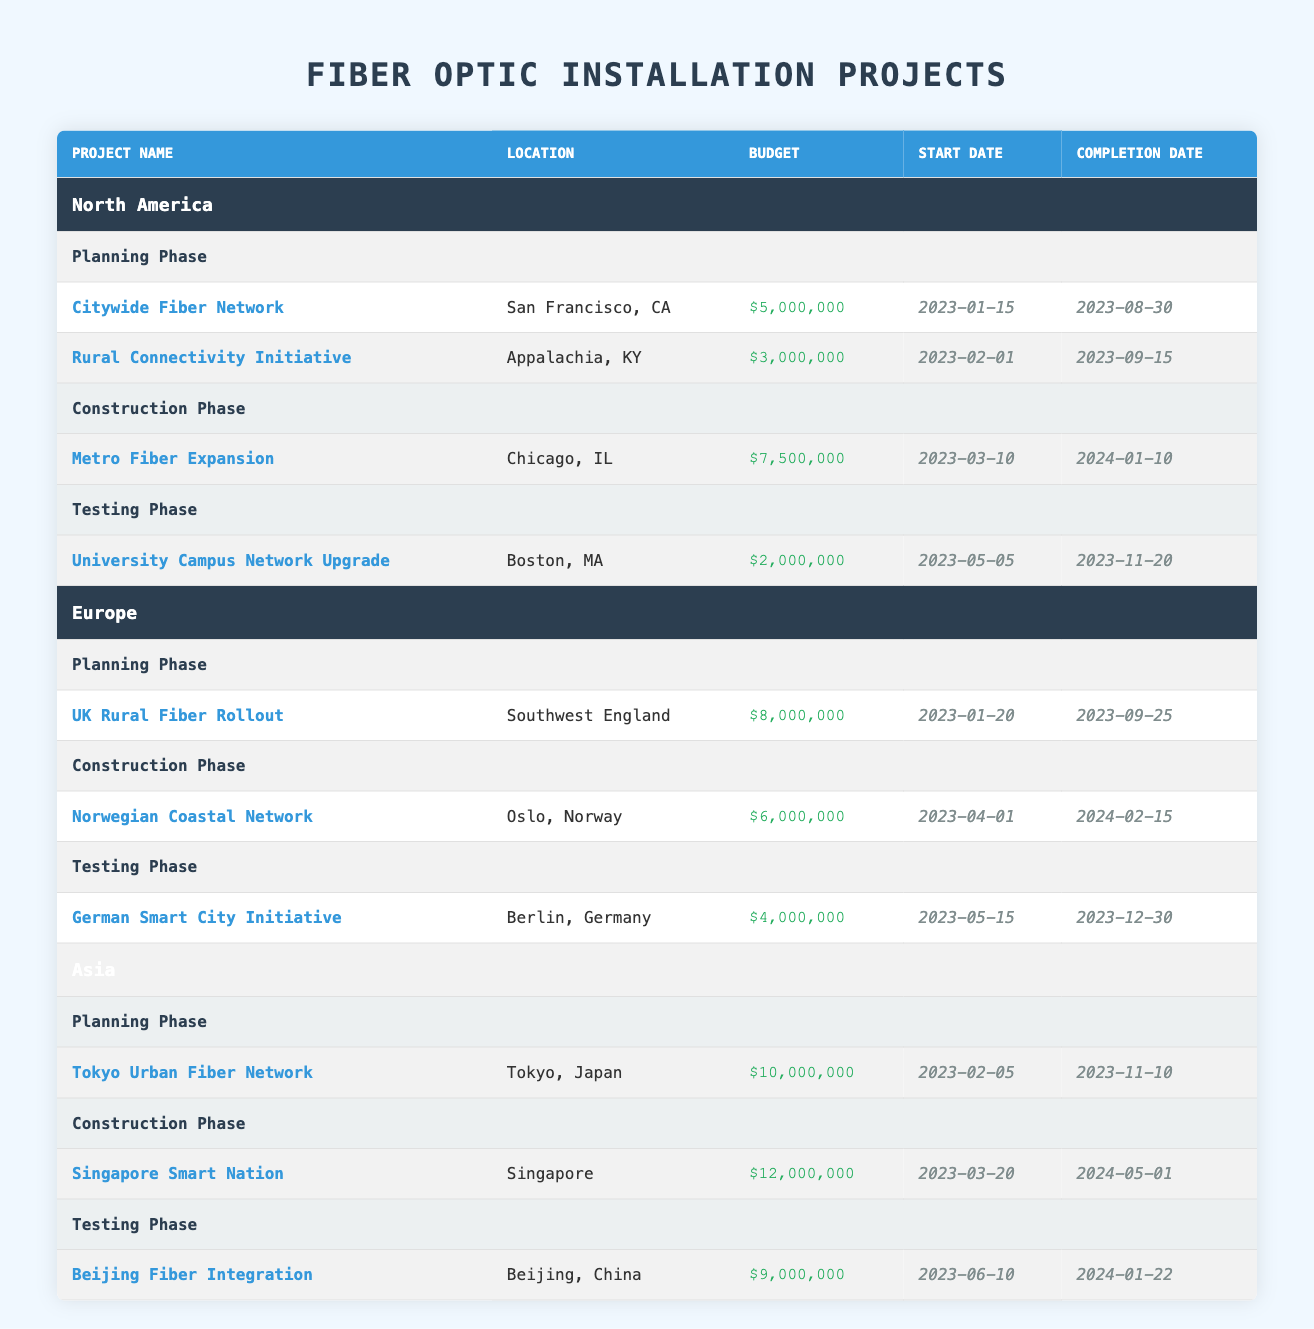What is the budget for the "Citywide Fiber Network" project? The budget can be found in the row corresponding to the "Citywide Fiber Network" project under the "North America" section and the "Planning Phase." The budget listed is $5,000,000.
Answer: $5,000,000 How many projects are currently in the Construction Phase in North America? There is one project listed under the "Construction Phase" for North America, which is the "Metro Fiber Expansion."
Answer: 1 What is the total budget for projects in the Testing Phase across all regions? The budgets for the Testing Phase projects are: $2,000,000 (University Campus Network Upgrade) + $4,000,000 (German Smart City Initiative) + $9,000,000 (Beijing Fiber Integration) = $15,000,000.
Answer: $15,000,000 Is there a fiber optic project located in Berlin, Germany? The table includes a project in Berlin, Germany, specifically the "German Smart City Initiative" under the "Testing Phase." Therefore, the answer is yes.
Answer: Yes Which region has the highest budget for a single Planning Phase project? The Planning Phase project with the highest budget is "Tokyo Urban Fiber Network" in Asia, with a budget of $10,000,000. This is compared against other single projects in Europe and North America.
Answer: Asia How many projects are listed under the Construction Phase in Europe and what is their total budget? Europe has one Construction Phase project, which is the "Norwegian Coastal Network" with a budget of $6,000,000. Since there is only one project, the total budget is also $6,000,000.
Answer: 1 project, $6,000,000 What is the difference in budget between the "Rural Connectivity Initiative" and the "Singapore Smart Nation" projects? The "Rural Connectivity Initiative" has a budget of $3,000,000, and the "Singapore Smart Nation" has a budget of $12,000,000. The difference is calculated as $12,000,000 - $3,000,000 = $9,000,000.
Answer: $9,000,000 Are there more projects in the Planning or Construction phases across all regions? In total, Planning Phases have 4 projects (2 in North America, 1 in Europe, 1 in Asia), while Construction Phases have 3 projects (1 in North America, 1 in Europe, 1 in Asia). Therefore, there are more Planning Phase projects.
Answer: Yes, Planning Phase has more projects What is the earliest start date among all projects listed? By examining the start dates of all projects, "Citywide Fiber Network" has the earliest start date of 2023-01-15.
Answer: 2023-01-15 